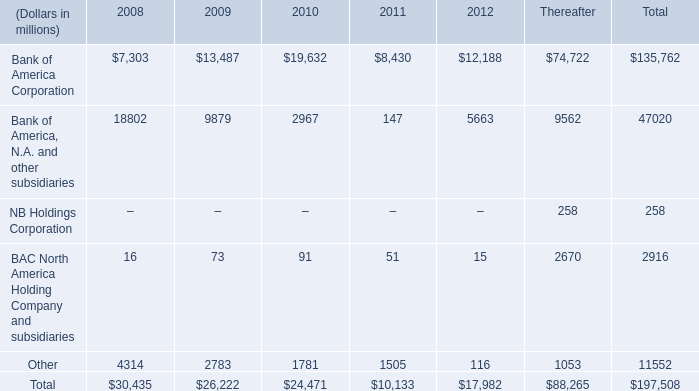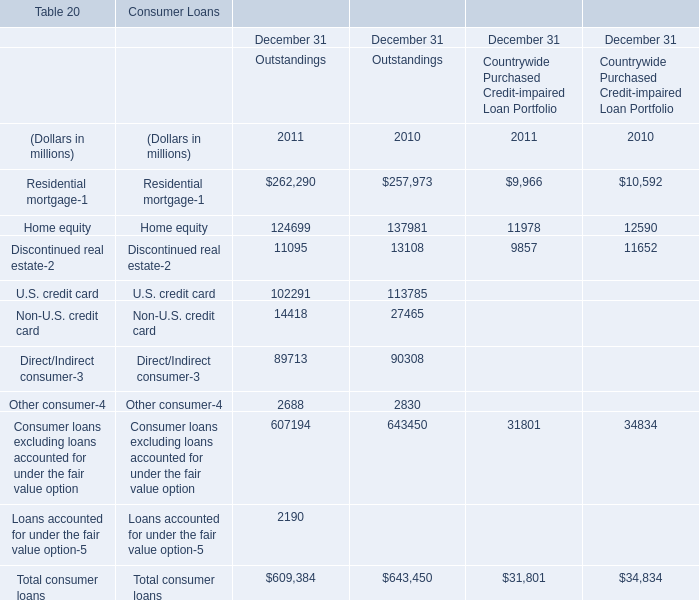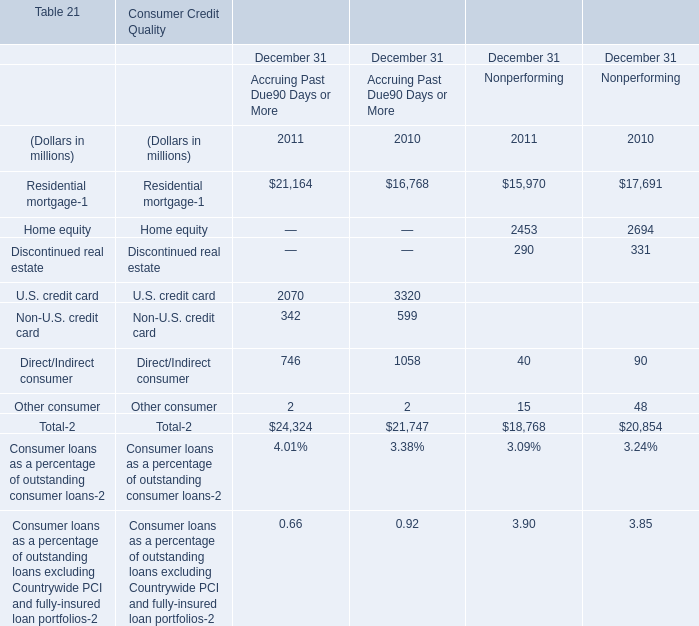What's the average of the U.S. credit card in table 2 in the years where Non-U.S. credit card in table 2 is positive? (in millions) 
Answer: 2070. what's the total amount of Residential mortgage of Consumer Loans December 31 Outstandings 2011, and Home equity of Consumer Credit Quality December 31 Nonperforming 2011 ? 
Computations: (262290.0 + 2453.0)
Answer: 264743.0. 